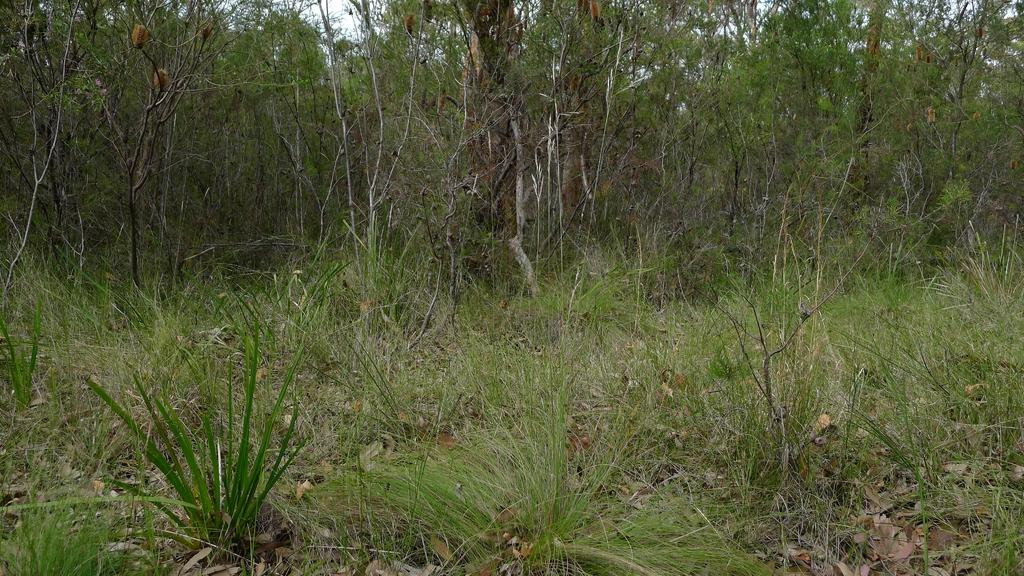What type of vegetation can be seen in the image? There are trees in the image. What type of ground cover is present at the bottom of the image? There is grass at the bottom of the image. What type of waste can be seen in the image? There is no waste present in the image; it features trees and grass. Is there a mine visible in the image? There is no mine present in the image; it features trees and grass. 